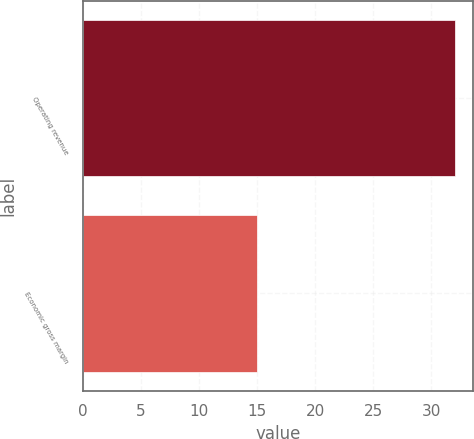Convert chart to OTSL. <chart><loc_0><loc_0><loc_500><loc_500><bar_chart><fcel>Operating revenue<fcel>Economic gross margin<nl><fcel>32<fcel>15<nl></chart> 